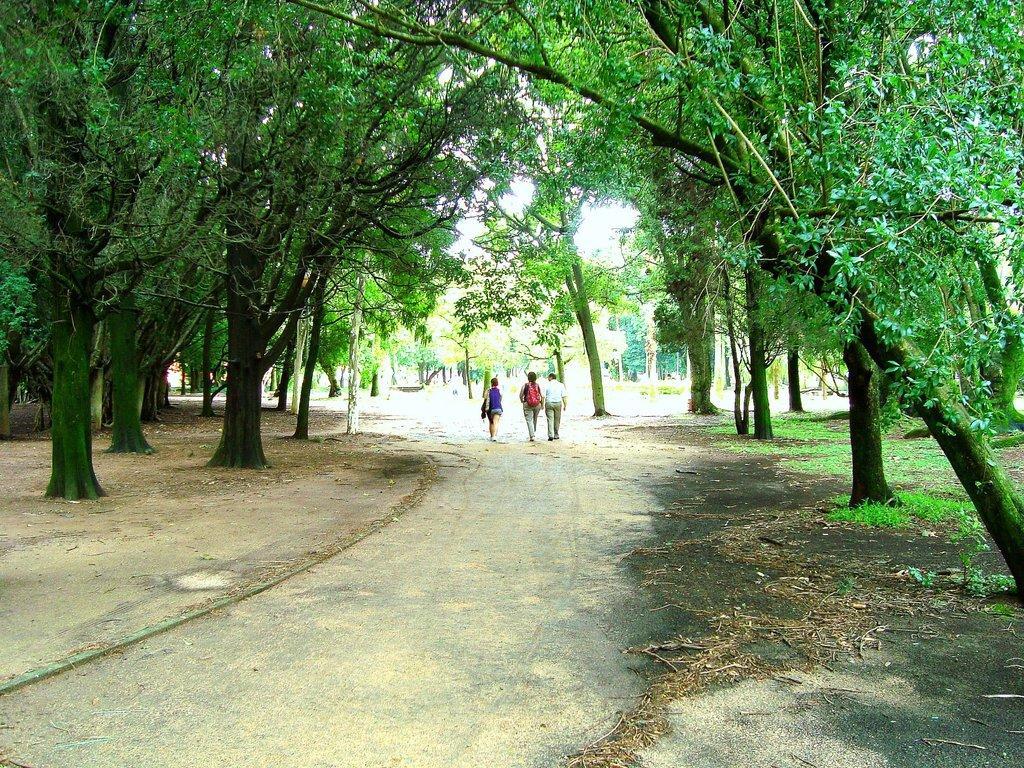Please provide a concise description of this image. In this image we can see three persons walking on the road. Here we can see the trees on the left side and the right side as well. 